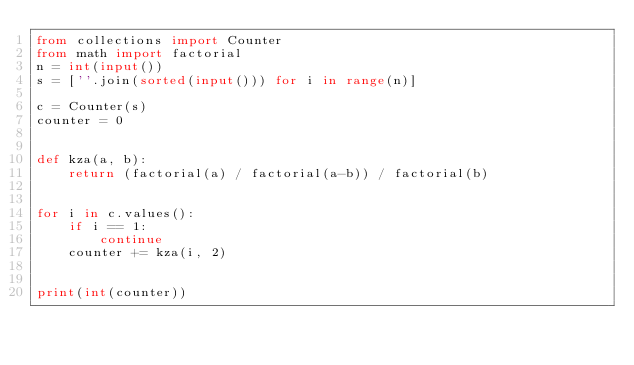Convert code to text. <code><loc_0><loc_0><loc_500><loc_500><_Python_>from collections import Counter
from math import factorial
n = int(input())
s = [''.join(sorted(input())) for i in range(n)]

c = Counter(s)
counter = 0


def kza(a, b):
    return (factorial(a) / factorial(a-b)) / factorial(b)


for i in c.values():
    if i == 1:
        continue
    counter += kza(i, 2)


print(int(counter))











</code> 